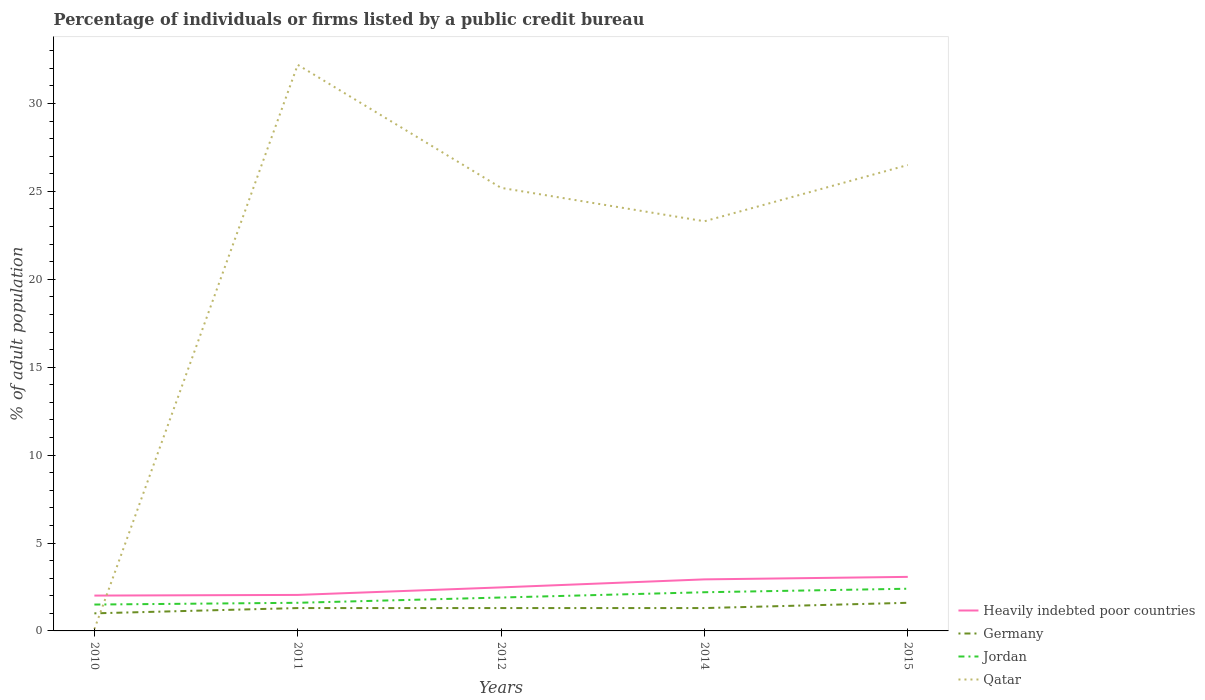Does the line corresponding to Heavily indebted poor countries intersect with the line corresponding to Jordan?
Keep it short and to the point. No. Is the number of lines equal to the number of legend labels?
Your answer should be very brief. Yes. What is the total percentage of population listed by a public credit bureau in Jordan in the graph?
Provide a succinct answer. -0.1. What is the difference between the highest and the second highest percentage of population listed by a public credit bureau in Jordan?
Offer a very short reply. 0.9. What is the difference between the highest and the lowest percentage of population listed by a public credit bureau in Qatar?
Provide a succinct answer. 4. How many years are there in the graph?
Offer a terse response. 5. Are the values on the major ticks of Y-axis written in scientific E-notation?
Keep it short and to the point. No. Does the graph contain any zero values?
Keep it short and to the point. No. Where does the legend appear in the graph?
Ensure brevity in your answer.  Bottom right. How many legend labels are there?
Make the answer very short. 4. What is the title of the graph?
Give a very brief answer. Percentage of individuals or firms listed by a public credit bureau. Does "High income: nonOECD" appear as one of the legend labels in the graph?
Ensure brevity in your answer.  No. What is the label or title of the Y-axis?
Make the answer very short. % of adult population. What is the % of adult population of Heavily indebted poor countries in 2010?
Provide a short and direct response. 2.01. What is the % of adult population of Qatar in 2010?
Keep it short and to the point. 0.1. What is the % of adult population of Heavily indebted poor countries in 2011?
Your answer should be compact. 2.05. What is the % of adult population of Qatar in 2011?
Provide a succinct answer. 32.2. What is the % of adult population of Heavily indebted poor countries in 2012?
Ensure brevity in your answer.  2.48. What is the % of adult population in Qatar in 2012?
Keep it short and to the point. 25.2. What is the % of adult population of Heavily indebted poor countries in 2014?
Offer a very short reply. 2.93. What is the % of adult population in Qatar in 2014?
Your answer should be very brief. 23.3. What is the % of adult population in Heavily indebted poor countries in 2015?
Give a very brief answer. 3.07. What is the % of adult population in Jordan in 2015?
Give a very brief answer. 2.4. What is the % of adult population in Qatar in 2015?
Offer a terse response. 26.5. Across all years, what is the maximum % of adult population of Heavily indebted poor countries?
Your response must be concise. 3.07. Across all years, what is the maximum % of adult population in Jordan?
Give a very brief answer. 2.4. Across all years, what is the maximum % of adult population in Qatar?
Provide a succinct answer. 32.2. Across all years, what is the minimum % of adult population in Heavily indebted poor countries?
Give a very brief answer. 2.01. Across all years, what is the minimum % of adult population of Germany?
Ensure brevity in your answer.  1. Across all years, what is the minimum % of adult population in Jordan?
Keep it short and to the point. 1.5. Across all years, what is the minimum % of adult population in Qatar?
Provide a short and direct response. 0.1. What is the total % of adult population in Heavily indebted poor countries in the graph?
Make the answer very short. 12.54. What is the total % of adult population in Qatar in the graph?
Give a very brief answer. 107.3. What is the difference between the % of adult population in Heavily indebted poor countries in 2010 and that in 2011?
Keep it short and to the point. -0.04. What is the difference between the % of adult population of Germany in 2010 and that in 2011?
Offer a terse response. -0.3. What is the difference between the % of adult population in Qatar in 2010 and that in 2011?
Your answer should be very brief. -32.1. What is the difference between the % of adult population in Heavily indebted poor countries in 2010 and that in 2012?
Your response must be concise. -0.47. What is the difference between the % of adult population in Germany in 2010 and that in 2012?
Offer a very short reply. -0.3. What is the difference between the % of adult population of Jordan in 2010 and that in 2012?
Your response must be concise. -0.4. What is the difference between the % of adult population of Qatar in 2010 and that in 2012?
Offer a very short reply. -25.1. What is the difference between the % of adult population in Heavily indebted poor countries in 2010 and that in 2014?
Offer a terse response. -0.92. What is the difference between the % of adult population of Germany in 2010 and that in 2014?
Your answer should be compact. -0.3. What is the difference between the % of adult population in Qatar in 2010 and that in 2014?
Your answer should be very brief. -23.2. What is the difference between the % of adult population in Heavily indebted poor countries in 2010 and that in 2015?
Ensure brevity in your answer.  -1.06. What is the difference between the % of adult population in Germany in 2010 and that in 2015?
Offer a terse response. -0.6. What is the difference between the % of adult population of Qatar in 2010 and that in 2015?
Ensure brevity in your answer.  -26.4. What is the difference between the % of adult population of Heavily indebted poor countries in 2011 and that in 2012?
Offer a very short reply. -0.43. What is the difference between the % of adult population of Germany in 2011 and that in 2012?
Your answer should be very brief. 0. What is the difference between the % of adult population in Qatar in 2011 and that in 2012?
Your answer should be compact. 7. What is the difference between the % of adult population of Heavily indebted poor countries in 2011 and that in 2014?
Give a very brief answer. -0.88. What is the difference between the % of adult population in Heavily indebted poor countries in 2011 and that in 2015?
Offer a terse response. -1.03. What is the difference between the % of adult population of Jordan in 2011 and that in 2015?
Your response must be concise. -0.8. What is the difference between the % of adult population in Heavily indebted poor countries in 2012 and that in 2014?
Make the answer very short. -0.46. What is the difference between the % of adult population of Germany in 2012 and that in 2014?
Provide a succinct answer. 0. What is the difference between the % of adult population of Jordan in 2012 and that in 2014?
Offer a terse response. -0.3. What is the difference between the % of adult population in Qatar in 2012 and that in 2014?
Your answer should be very brief. 1.9. What is the difference between the % of adult population in Heavily indebted poor countries in 2012 and that in 2015?
Provide a succinct answer. -0.6. What is the difference between the % of adult population in Germany in 2012 and that in 2015?
Keep it short and to the point. -0.3. What is the difference between the % of adult population of Qatar in 2012 and that in 2015?
Provide a short and direct response. -1.3. What is the difference between the % of adult population of Heavily indebted poor countries in 2014 and that in 2015?
Ensure brevity in your answer.  -0.14. What is the difference between the % of adult population of Germany in 2014 and that in 2015?
Make the answer very short. -0.3. What is the difference between the % of adult population of Jordan in 2014 and that in 2015?
Provide a succinct answer. -0.2. What is the difference between the % of adult population of Qatar in 2014 and that in 2015?
Offer a very short reply. -3.2. What is the difference between the % of adult population in Heavily indebted poor countries in 2010 and the % of adult population in Germany in 2011?
Offer a very short reply. 0.71. What is the difference between the % of adult population in Heavily indebted poor countries in 2010 and the % of adult population in Jordan in 2011?
Give a very brief answer. 0.41. What is the difference between the % of adult population in Heavily indebted poor countries in 2010 and the % of adult population in Qatar in 2011?
Give a very brief answer. -30.19. What is the difference between the % of adult population in Germany in 2010 and the % of adult population in Jordan in 2011?
Your answer should be very brief. -0.6. What is the difference between the % of adult population of Germany in 2010 and the % of adult population of Qatar in 2011?
Provide a succinct answer. -31.2. What is the difference between the % of adult population in Jordan in 2010 and the % of adult population in Qatar in 2011?
Provide a succinct answer. -30.7. What is the difference between the % of adult population in Heavily indebted poor countries in 2010 and the % of adult population in Germany in 2012?
Keep it short and to the point. 0.71. What is the difference between the % of adult population of Heavily indebted poor countries in 2010 and the % of adult population of Jordan in 2012?
Ensure brevity in your answer.  0.11. What is the difference between the % of adult population of Heavily indebted poor countries in 2010 and the % of adult population of Qatar in 2012?
Offer a very short reply. -23.19. What is the difference between the % of adult population in Germany in 2010 and the % of adult population in Qatar in 2012?
Make the answer very short. -24.2. What is the difference between the % of adult population of Jordan in 2010 and the % of adult population of Qatar in 2012?
Your answer should be very brief. -23.7. What is the difference between the % of adult population of Heavily indebted poor countries in 2010 and the % of adult population of Germany in 2014?
Give a very brief answer. 0.71. What is the difference between the % of adult population of Heavily indebted poor countries in 2010 and the % of adult population of Jordan in 2014?
Give a very brief answer. -0.19. What is the difference between the % of adult population of Heavily indebted poor countries in 2010 and the % of adult population of Qatar in 2014?
Offer a terse response. -21.29. What is the difference between the % of adult population in Germany in 2010 and the % of adult population in Qatar in 2014?
Give a very brief answer. -22.3. What is the difference between the % of adult population in Jordan in 2010 and the % of adult population in Qatar in 2014?
Provide a short and direct response. -21.8. What is the difference between the % of adult population in Heavily indebted poor countries in 2010 and the % of adult population in Germany in 2015?
Your answer should be very brief. 0.41. What is the difference between the % of adult population of Heavily indebted poor countries in 2010 and the % of adult population of Jordan in 2015?
Offer a very short reply. -0.39. What is the difference between the % of adult population of Heavily indebted poor countries in 2010 and the % of adult population of Qatar in 2015?
Provide a succinct answer. -24.49. What is the difference between the % of adult population of Germany in 2010 and the % of adult population of Qatar in 2015?
Your response must be concise. -25.5. What is the difference between the % of adult population of Heavily indebted poor countries in 2011 and the % of adult population of Germany in 2012?
Your answer should be very brief. 0.75. What is the difference between the % of adult population in Heavily indebted poor countries in 2011 and the % of adult population in Jordan in 2012?
Your response must be concise. 0.15. What is the difference between the % of adult population of Heavily indebted poor countries in 2011 and the % of adult population of Qatar in 2012?
Make the answer very short. -23.15. What is the difference between the % of adult population in Germany in 2011 and the % of adult population in Qatar in 2012?
Make the answer very short. -23.9. What is the difference between the % of adult population of Jordan in 2011 and the % of adult population of Qatar in 2012?
Keep it short and to the point. -23.6. What is the difference between the % of adult population of Heavily indebted poor countries in 2011 and the % of adult population of Germany in 2014?
Give a very brief answer. 0.75. What is the difference between the % of adult population of Heavily indebted poor countries in 2011 and the % of adult population of Jordan in 2014?
Offer a terse response. -0.15. What is the difference between the % of adult population of Heavily indebted poor countries in 2011 and the % of adult population of Qatar in 2014?
Your response must be concise. -21.25. What is the difference between the % of adult population in Jordan in 2011 and the % of adult population in Qatar in 2014?
Your answer should be very brief. -21.7. What is the difference between the % of adult population of Heavily indebted poor countries in 2011 and the % of adult population of Germany in 2015?
Make the answer very short. 0.45. What is the difference between the % of adult population of Heavily indebted poor countries in 2011 and the % of adult population of Jordan in 2015?
Give a very brief answer. -0.35. What is the difference between the % of adult population of Heavily indebted poor countries in 2011 and the % of adult population of Qatar in 2015?
Make the answer very short. -24.45. What is the difference between the % of adult population of Germany in 2011 and the % of adult population of Jordan in 2015?
Offer a very short reply. -1.1. What is the difference between the % of adult population in Germany in 2011 and the % of adult population in Qatar in 2015?
Your response must be concise. -25.2. What is the difference between the % of adult population in Jordan in 2011 and the % of adult population in Qatar in 2015?
Give a very brief answer. -24.9. What is the difference between the % of adult population of Heavily indebted poor countries in 2012 and the % of adult population of Germany in 2014?
Your answer should be very brief. 1.18. What is the difference between the % of adult population of Heavily indebted poor countries in 2012 and the % of adult population of Jordan in 2014?
Provide a short and direct response. 0.28. What is the difference between the % of adult population of Heavily indebted poor countries in 2012 and the % of adult population of Qatar in 2014?
Make the answer very short. -20.82. What is the difference between the % of adult population of Jordan in 2012 and the % of adult population of Qatar in 2014?
Make the answer very short. -21.4. What is the difference between the % of adult population of Heavily indebted poor countries in 2012 and the % of adult population of Germany in 2015?
Ensure brevity in your answer.  0.88. What is the difference between the % of adult population in Heavily indebted poor countries in 2012 and the % of adult population in Jordan in 2015?
Your answer should be very brief. 0.08. What is the difference between the % of adult population in Heavily indebted poor countries in 2012 and the % of adult population in Qatar in 2015?
Your response must be concise. -24.02. What is the difference between the % of adult population of Germany in 2012 and the % of adult population of Jordan in 2015?
Ensure brevity in your answer.  -1.1. What is the difference between the % of adult population in Germany in 2012 and the % of adult population in Qatar in 2015?
Your response must be concise. -25.2. What is the difference between the % of adult population in Jordan in 2012 and the % of adult population in Qatar in 2015?
Give a very brief answer. -24.6. What is the difference between the % of adult population in Heavily indebted poor countries in 2014 and the % of adult population in Germany in 2015?
Provide a succinct answer. 1.33. What is the difference between the % of adult population in Heavily indebted poor countries in 2014 and the % of adult population in Jordan in 2015?
Provide a succinct answer. 0.53. What is the difference between the % of adult population in Heavily indebted poor countries in 2014 and the % of adult population in Qatar in 2015?
Offer a very short reply. -23.57. What is the difference between the % of adult population in Germany in 2014 and the % of adult population in Jordan in 2015?
Ensure brevity in your answer.  -1.1. What is the difference between the % of adult population of Germany in 2014 and the % of adult population of Qatar in 2015?
Give a very brief answer. -25.2. What is the difference between the % of adult population of Jordan in 2014 and the % of adult population of Qatar in 2015?
Your answer should be compact. -24.3. What is the average % of adult population of Heavily indebted poor countries per year?
Keep it short and to the point. 2.51. What is the average % of adult population of Germany per year?
Make the answer very short. 1.3. What is the average % of adult population in Jordan per year?
Ensure brevity in your answer.  1.92. What is the average % of adult population in Qatar per year?
Offer a very short reply. 21.46. In the year 2010, what is the difference between the % of adult population of Heavily indebted poor countries and % of adult population of Germany?
Your response must be concise. 1.01. In the year 2010, what is the difference between the % of adult population of Heavily indebted poor countries and % of adult population of Jordan?
Keep it short and to the point. 0.51. In the year 2010, what is the difference between the % of adult population of Heavily indebted poor countries and % of adult population of Qatar?
Provide a succinct answer. 1.91. In the year 2010, what is the difference between the % of adult population of Germany and % of adult population of Jordan?
Keep it short and to the point. -0.5. In the year 2010, what is the difference between the % of adult population in Germany and % of adult population in Qatar?
Your response must be concise. 0.9. In the year 2011, what is the difference between the % of adult population of Heavily indebted poor countries and % of adult population of Germany?
Keep it short and to the point. 0.75. In the year 2011, what is the difference between the % of adult population in Heavily indebted poor countries and % of adult population in Jordan?
Make the answer very short. 0.45. In the year 2011, what is the difference between the % of adult population of Heavily indebted poor countries and % of adult population of Qatar?
Your response must be concise. -30.15. In the year 2011, what is the difference between the % of adult population in Germany and % of adult population in Jordan?
Keep it short and to the point. -0.3. In the year 2011, what is the difference between the % of adult population in Germany and % of adult population in Qatar?
Provide a short and direct response. -30.9. In the year 2011, what is the difference between the % of adult population in Jordan and % of adult population in Qatar?
Keep it short and to the point. -30.6. In the year 2012, what is the difference between the % of adult population in Heavily indebted poor countries and % of adult population in Germany?
Your answer should be very brief. 1.18. In the year 2012, what is the difference between the % of adult population of Heavily indebted poor countries and % of adult population of Jordan?
Your answer should be compact. 0.58. In the year 2012, what is the difference between the % of adult population of Heavily indebted poor countries and % of adult population of Qatar?
Provide a short and direct response. -22.72. In the year 2012, what is the difference between the % of adult population in Germany and % of adult population in Qatar?
Provide a short and direct response. -23.9. In the year 2012, what is the difference between the % of adult population of Jordan and % of adult population of Qatar?
Give a very brief answer. -23.3. In the year 2014, what is the difference between the % of adult population of Heavily indebted poor countries and % of adult population of Germany?
Provide a succinct answer. 1.63. In the year 2014, what is the difference between the % of adult population of Heavily indebted poor countries and % of adult population of Jordan?
Provide a short and direct response. 0.73. In the year 2014, what is the difference between the % of adult population in Heavily indebted poor countries and % of adult population in Qatar?
Offer a terse response. -20.37. In the year 2014, what is the difference between the % of adult population of Jordan and % of adult population of Qatar?
Provide a short and direct response. -21.1. In the year 2015, what is the difference between the % of adult population in Heavily indebted poor countries and % of adult population in Germany?
Give a very brief answer. 1.47. In the year 2015, what is the difference between the % of adult population of Heavily indebted poor countries and % of adult population of Jordan?
Give a very brief answer. 0.67. In the year 2015, what is the difference between the % of adult population of Heavily indebted poor countries and % of adult population of Qatar?
Your response must be concise. -23.43. In the year 2015, what is the difference between the % of adult population of Germany and % of adult population of Qatar?
Ensure brevity in your answer.  -24.9. In the year 2015, what is the difference between the % of adult population of Jordan and % of adult population of Qatar?
Your response must be concise. -24.1. What is the ratio of the % of adult population of Heavily indebted poor countries in 2010 to that in 2011?
Provide a short and direct response. 0.98. What is the ratio of the % of adult population in Germany in 2010 to that in 2011?
Your answer should be compact. 0.77. What is the ratio of the % of adult population of Jordan in 2010 to that in 2011?
Ensure brevity in your answer.  0.94. What is the ratio of the % of adult population in Qatar in 2010 to that in 2011?
Ensure brevity in your answer.  0. What is the ratio of the % of adult population in Heavily indebted poor countries in 2010 to that in 2012?
Offer a terse response. 0.81. What is the ratio of the % of adult population in Germany in 2010 to that in 2012?
Your response must be concise. 0.77. What is the ratio of the % of adult population in Jordan in 2010 to that in 2012?
Give a very brief answer. 0.79. What is the ratio of the % of adult population of Qatar in 2010 to that in 2012?
Your answer should be compact. 0. What is the ratio of the % of adult population in Heavily indebted poor countries in 2010 to that in 2014?
Ensure brevity in your answer.  0.69. What is the ratio of the % of adult population in Germany in 2010 to that in 2014?
Your answer should be very brief. 0.77. What is the ratio of the % of adult population of Jordan in 2010 to that in 2014?
Offer a very short reply. 0.68. What is the ratio of the % of adult population in Qatar in 2010 to that in 2014?
Your answer should be compact. 0. What is the ratio of the % of adult population of Heavily indebted poor countries in 2010 to that in 2015?
Provide a short and direct response. 0.65. What is the ratio of the % of adult population in Jordan in 2010 to that in 2015?
Your response must be concise. 0.62. What is the ratio of the % of adult population of Qatar in 2010 to that in 2015?
Your response must be concise. 0. What is the ratio of the % of adult population in Heavily indebted poor countries in 2011 to that in 2012?
Your answer should be very brief. 0.83. What is the ratio of the % of adult population in Germany in 2011 to that in 2012?
Your response must be concise. 1. What is the ratio of the % of adult population in Jordan in 2011 to that in 2012?
Your answer should be compact. 0.84. What is the ratio of the % of adult population in Qatar in 2011 to that in 2012?
Keep it short and to the point. 1.28. What is the ratio of the % of adult population in Heavily indebted poor countries in 2011 to that in 2014?
Make the answer very short. 0.7. What is the ratio of the % of adult population of Jordan in 2011 to that in 2014?
Provide a succinct answer. 0.73. What is the ratio of the % of adult population of Qatar in 2011 to that in 2014?
Ensure brevity in your answer.  1.38. What is the ratio of the % of adult population of Heavily indebted poor countries in 2011 to that in 2015?
Give a very brief answer. 0.67. What is the ratio of the % of adult population in Germany in 2011 to that in 2015?
Offer a terse response. 0.81. What is the ratio of the % of adult population in Qatar in 2011 to that in 2015?
Ensure brevity in your answer.  1.22. What is the ratio of the % of adult population in Heavily indebted poor countries in 2012 to that in 2014?
Provide a short and direct response. 0.84. What is the ratio of the % of adult population of Jordan in 2012 to that in 2014?
Your response must be concise. 0.86. What is the ratio of the % of adult population in Qatar in 2012 to that in 2014?
Provide a succinct answer. 1.08. What is the ratio of the % of adult population of Heavily indebted poor countries in 2012 to that in 2015?
Your response must be concise. 0.81. What is the ratio of the % of adult population in Germany in 2012 to that in 2015?
Provide a short and direct response. 0.81. What is the ratio of the % of adult population in Jordan in 2012 to that in 2015?
Offer a terse response. 0.79. What is the ratio of the % of adult population in Qatar in 2012 to that in 2015?
Ensure brevity in your answer.  0.95. What is the ratio of the % of adult population in Heavily indebted poor countries in 2014 to that in 2015?
Make the answer very short. 0.95. What is the ratio of the % of adult population of Germany in 2014 to that in 2015?
Provide a succinct answer. 0.81. What is the ratio of the % of adult population of Qatar in 2014 to that in 2015?
Ensure brevity in your answer.  0.88. What is the difference between the highest and the second highest % of adult population in Heavily indebted poor countries?
Provide a succinct answer. 0.14. What is the difference between the highest and the second highest % of adult population of Germany?
Offer a terse response. 0.3. What is the difference between the highest and the second highest % of adult population in Jordan?
Your answer should be compact. 0.2. What is the difference between the highest and the second highest % of adult population in Qatar?
Keep it short and to the point. 5.7. What is the difference between the highest and the lowest % of adult population of Heavily indebted poor countries?
Your answer should be compact. 1.06. What is the difference between the highest and the lowest % of adult population of Qatar?
Keep it short and to the point. 32.1. 